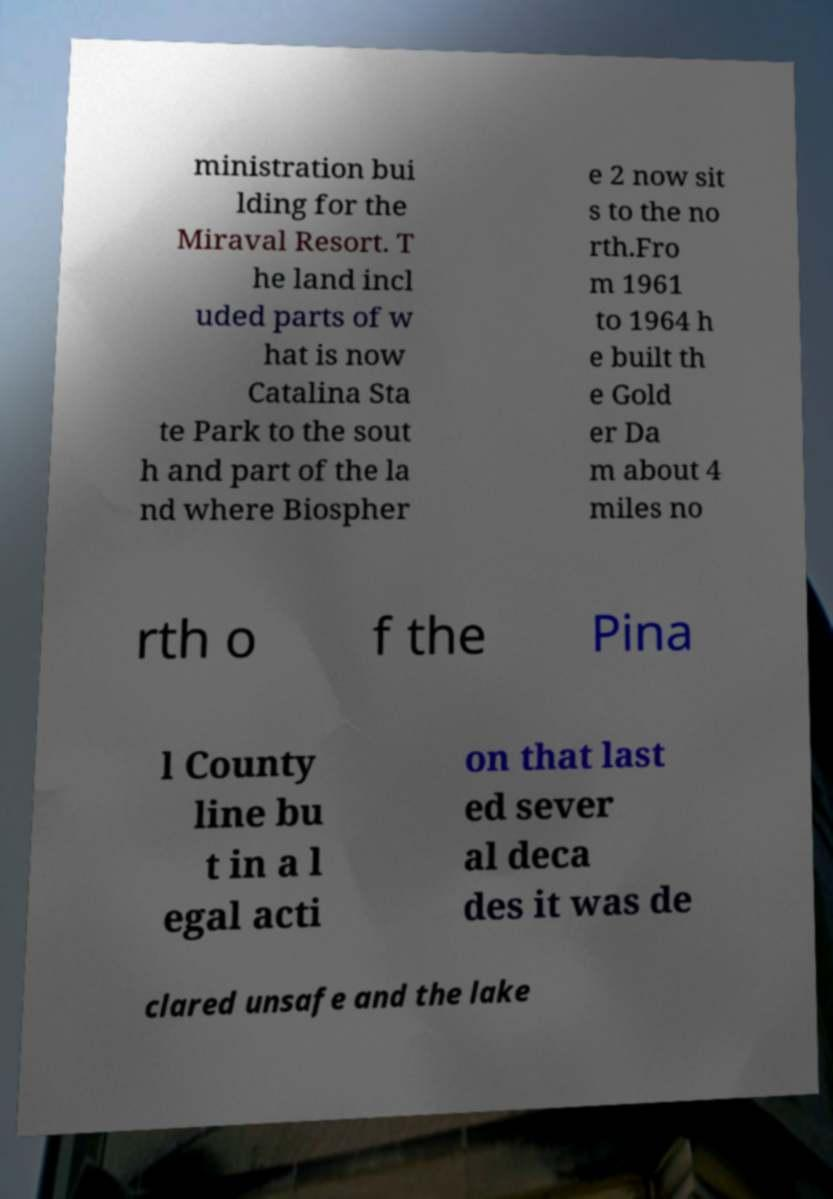Please identify and transcribe the text found in this image. ministration bui lding for the Miraval Resort. T he land incl uded parts of w hat is now Catalina Sta te Park to the sout h and part of the la nd where Biospher e 2 now sit s to the no rth.Fro m 1961 to 1964 h e built th e Gold er Da m about 4 miles no rth o f the Pina l County line bu t in a l egal acti on that last ed sever al deca des it was de clared unsafe and the lake 